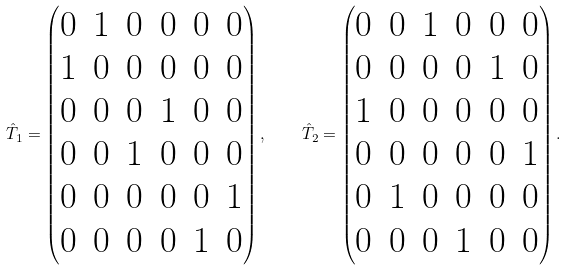<formula> <loc_0><loc_0><loc_500><loc_500>\hat { T } _ { 1 } = \left ( \begin{matrix} 0 & 1 & 0 & 0 & 0 & 0 \\ 1 & 0 & 0 & 0 & 0 & 0 \\ 0 & 0 & 0 & 1 & 0 & 0 \\ 0 & 0 & 1 & 0 & 0 & 0 \\ 0 & 0 & 0 & 0 & 0 & 1 \\ 0 & 0 & 0 & 0 & 1 & 0 \end{matrix} \right ) , \quad \hat { T } _ { 2 } = \left ( \begin{matrix} 0 & 0 & 1 & 0 & 0 & 0 \\ 0 & 0 & 0 & 0 & 1 & 0 \\ 1 & 0 & 0 & 0 & 0 & 0 \\ 0 & 0 & 0 & 0 & 0 & 1 \\ 0 & 1 & 0 & 0 & 0 & 0 \\ 0 & 0 & 0 & 1 & 0 & 0 \end{matrix} \right ) .</formula> 